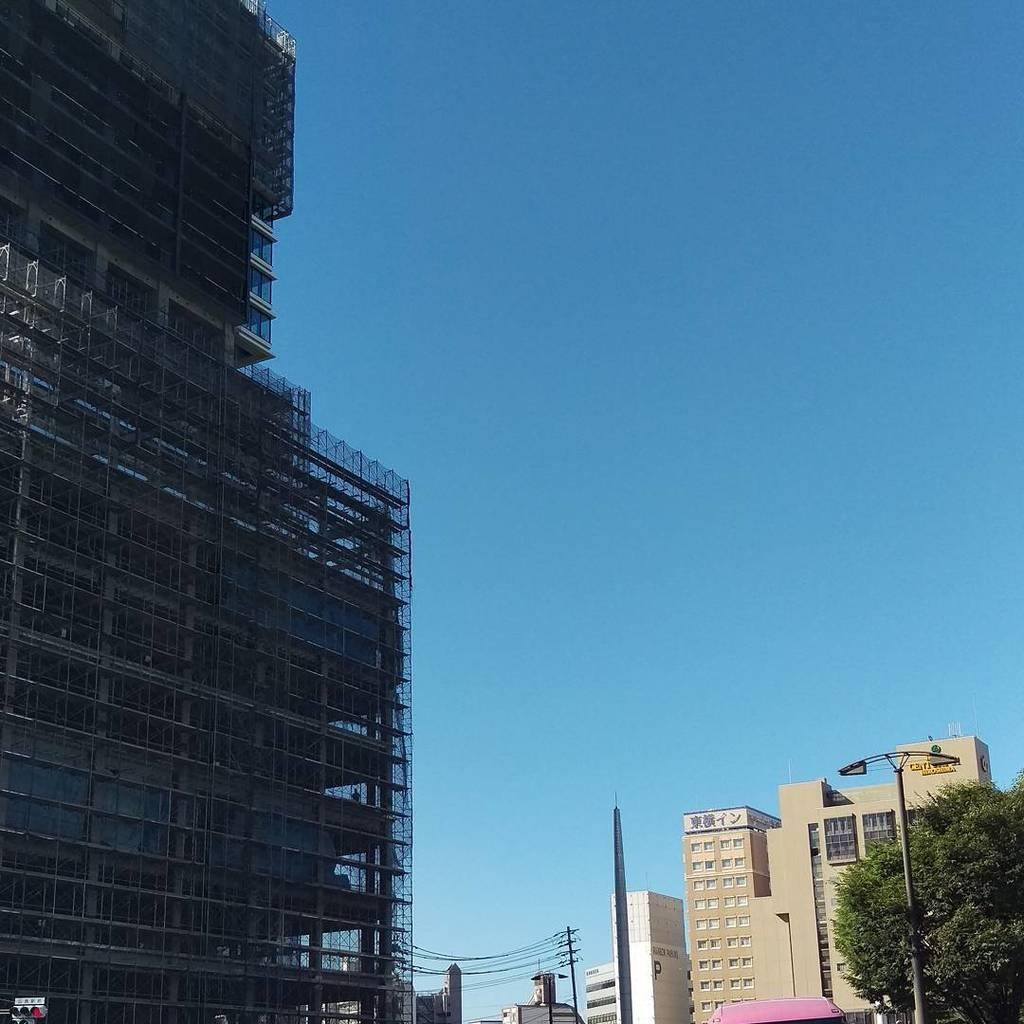What type of structures can be seen in the image? There are buildings in the image. What other natural elements are present in the image? There are trees in the image. What man-made object is present for illumination? There is a light pole in the image. What other man-made object is present for utility purposes? There is a pole with wires in the image. What can be seen in the background of the image? The sky is visible in the background of the image. How many waves can be seen crashing on the shore in the image? There are no waves present in the image; it features buildings, trees, a light pole, a pole with wires, and the sky. What type of horses are depicted in the image? There are no horses present in the image. 